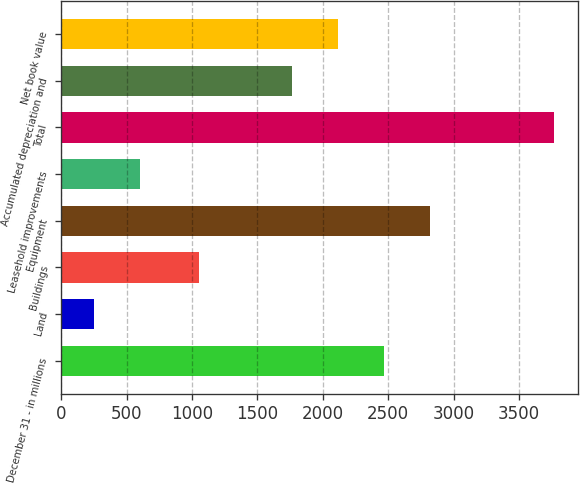Convert chart to OTSL. <chart><loc_0><loc_0><loc_500><loc_500><bar_chart><fcel>December 31 - in millions<fcel>Land<fcel>Buildings<fcel>Equipment<fcel>Leasehold improvements<fcel>Total<fcel>Accumulated depreciation and<fcel>Net book value<nl><fcel>2467<fcel>250<fcel>1053<fcel>2818.5<fcel>601.5<fcel>3765<fcel>1764<fcel>2115.5<nl></chart> 